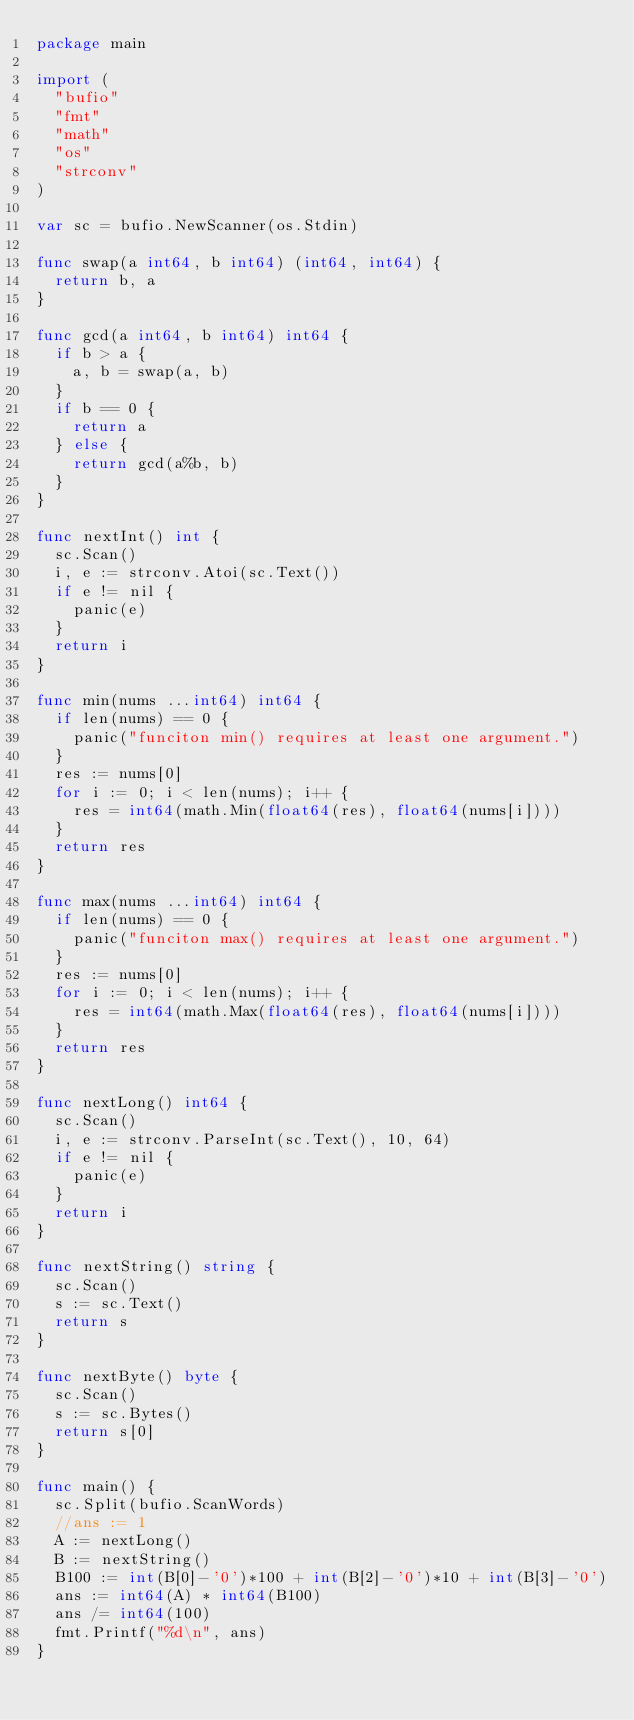Convert code to text. <code><loc_0><loc_0><loc_500><loc_500><_Go_>package main

import (
	"bufio"
	"fmt"
	"math"
	"os"
	"strconv"
)

var sc = bufio.NewScanner(os.Stdin)

func swap(a int64, b int64) (int64, int64) {
	return b, a
}

func gcd(a int64, b int64) int64 {
	if b > a {
		a, b = swap(a, b)
	}
	if b == 0 {
		return a
	} else {
		return gcd(a%b, b)
	}
}

func nextInt() int {
	sc.Scan()
	i, e := strconv.Atoi(sc.Text())
	if e != nil {
		panic(e)
	}
	return i
}

func min(nums ...int64) int64 {
	if len(nums) == 0 {
		panic("funciton min() requires at least one argument.")
	}
	res := nums[0]
	for i := 0; i < len(nums); i++ {
		res = int64(math.Min(float64(res), float64(nums[i])))
	}
	return res
}

func max(nums ...int64) int64 {
	if len(nums) == 0 {
		panic("funciton max() requires at least one argument.")
	}
	res := nums[0]
	for i := 0; i < len(nums); i++ {
		res = int64(math.Max(float64(res), float64(nums[i])))
	}
	return res
}

func nextLong() int64 {
	sc.Scan()
	i, e := strconv.ParseInt(sc.Text(), 10, 64)
	if e != nil {
		panic(e)
	}
	return i
}

func nextString() string {
	sc.Scan()
	s := sc.Text()
	return s
}

func nextByte() byte {
	sc.Scan()
	s := sc.Bytes()
	return s[0]
}

func main() {
	sc.Split(bufio.ScanWords)
	//ans := 1
	A := nextLong()
	B := nextString()
	B100 := int(B[0]-'0')*100 + int(B[2]-'0')*10 + int(B[3]-'0')
	ans := int64(A) * int64(B100)
	ans /= int64(100)
	fmt.Printf("%d\n", ans)
}
</code> 